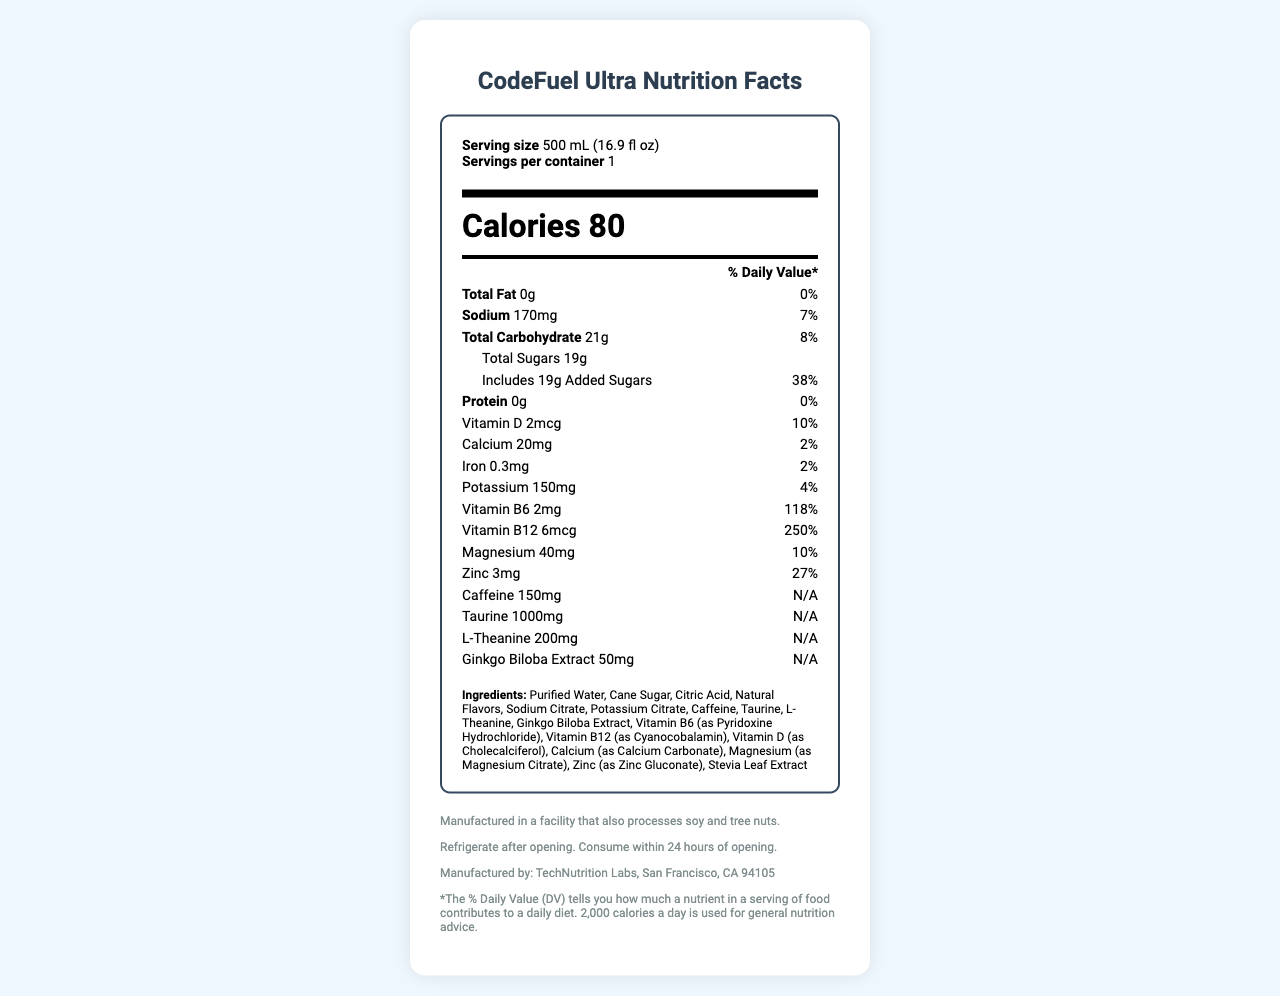what is the product name? The product name is clearly mentioned at the top of the document as "CodeFuel Ultra".
Answer: CodeFuel Ultra what is the serving size of the hydration drink? The serving size is specified under the section "Serving size" as "500 mL (16.9 fl oz)".
Answer: 500 mL (16.9 fl oz) how many calories are in one serving? The number of calories per serving is displayed prominently in the "Calories" section as 80.
Answer: 80 calories what is the daily value percentage of total fat? The daily value percentage of total fat is listed as 0% in the "Total Fat" section.
Answer: 0% which ingredient is present in the highest quantity? The ingredients are usually listed in descending order of quantity, and "Purified Water" is the first item listed under "Ingredients".
Answer: Purified Water how much sodium is in one serving? The sodium content per serving is shown as 170mg under the "Sodium" section.
Answer: 170mg what is the daily value percentage for vitamin D? The daily value percentage for vitamin D is noted as 10% in the "Vitamin D" section.
Answer: 10% what is the daily value percentage for added sugars? A. 8% B. 10% C. 38% D. 250% The daily value percentage for added sugars is shown as 38% in the section for "Includes 19g Added Sugars".
Answer: C how much vitamin B12 is present in one serving? The amount of vitamin B12 per serving is listed as 6mcg under the "Vitamin B12" section.
Answer: 6mcg what is the name of the manufacturer? The manufacturer is identified at the bottom of the document as "TechNutrition Labs, San Francisco, CA 94105".
Answer: TechNutrition Labs which of the following nutrients has the highest daily value percentage? i. Calcium ii. Magnesium iii. Zinc iv. Vitamin B6 Vitamin B6 has the highest daily value percentage of 118%, which is greater than the percentages for calcium, magnesium, and zinc.
Answer: iv. Vitamin B6 does the drink contain iron? The presence of iron is confirmed in the "Iron" section where it states 0.3mg.
Answer: Yes is the amount of protein present significant? The document states that the protein amount is 0g, which is not significant.
Answer: No summarize the nutritional composition of CodeFuel Ultra. The summary includes key nutritional information, showing calories, macronutrients, vitamins, minerals, and other ingredients.
Answer: CodeFuel Ultra is a vitamin-enriched hydration drink with 80 calories per serving. It contains 0g of total fat, 170mg of sodium (7% DV), 21g of total carbohydrate (8% DV) including 19g of added sugars (38% DV), and 0g of protein. It is rich in vitamin B6 (118% DV) and vitamin B12 (250% DV), with moderate amounts of vitamin D, calcium, magnesium, zinc, potassium, and iron. It also contains 150mg of caffeine, 1000mg of taurine, 200mg of L-Theanine, and 50mg of Ginkgo Biloba Extract. what is the specific effect of taurine in the drink? The document lists taurine as an ingredient but does not specify its effect or purpose.
Answer: Cannot be determined 